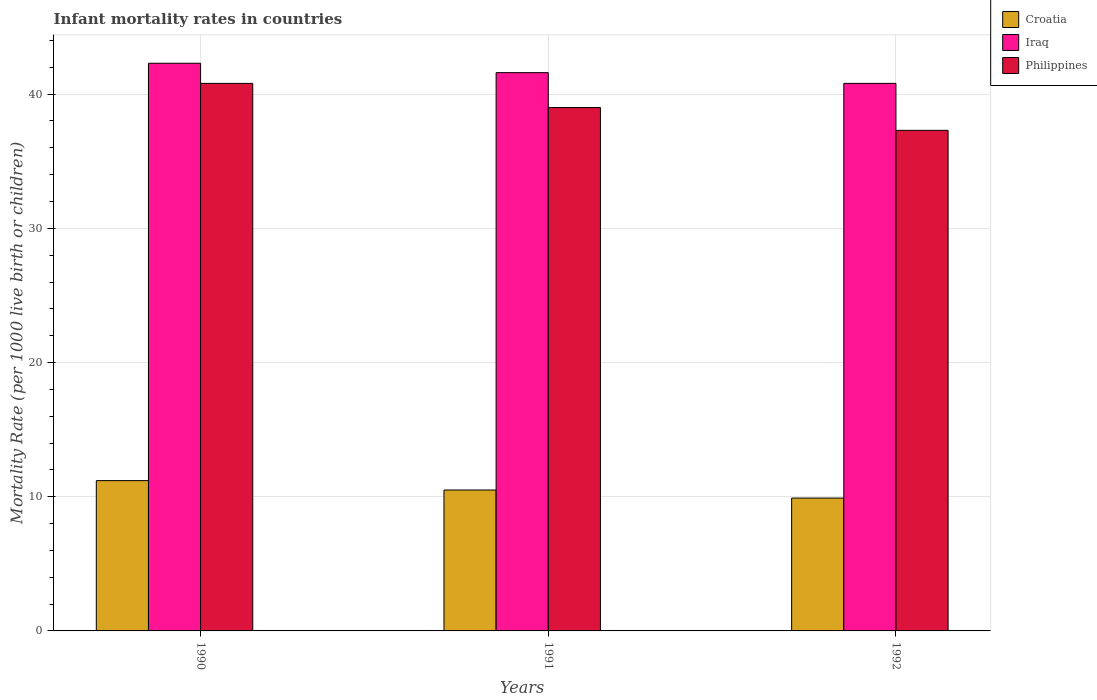How many different coloured bars are there?
Provide a short and direct response. 3. How many bars are there on the 3rd tick from the left?
Make the answer very short. 3. What is the label of the 1st group of bars from the left?
Keep it short and to the point. 1990. What is the infant mortality rate in Iraq in 1992?
Provide a short and direct response. 40.8. Across all years, what is the maximum infant mortality rate in Philippines?
Give a very brief answer. 40.8. In which year was the infant mortality rate in Croatia maximum?
Make the answer very short. 1990. In which year was the infant mortality rate in Croatia minimum?
Your answer should be compact. 1992. What is the total infant mortality rate in Croatia in the graph?
Your answer should be very brief. 31.6. What is the difference between the infant mortality rate in Croatia in 1991 and that in 1992?
Your response must be concise. 0.6. What is the difference between the infant mortality rate in Philippines in 1992 and the infant mortality rate in Croatia in 1990?
Ensure brevity in your answer.  26.1. What is the average infant mortality rate in Philippines per year?
Provide a succinct answer. 39.03. In the year 1991, what is the difference between the infant mortality rate in Philippines and infant mortality rate in Iraq?
Make the answer very short. -2.6. What is the ratio of the infant mortality rate in Philippines in 1990 to that in 1991?
Your response must be concise. 1.05. Is the infant mortality rate in Philippines in 1991 less than that in 1992?
Provide a short and direct response. No. Is the difference between the infant mortality rate in Philippines in 1990 and 1992 greater than the difference between the infant mortality rate in Iraq in 1990 and 1992?
Provide a succinct answer. Yes. What is the difference between the highest and the second highest infant mortality rate in Philippines?
Your answer should be compact. 1.8. What is the difference between the highest and the lowest infant mortality rate in Philippines?
Make the answer very short. 3.5. Is the sum of the infant mortality rate in Croatia in 1991 and 1992 greater than the maximum infant mortality rate in Philippines across all years?
Your response must be concise. No. What does the 1st bar from the left in 1990 represents?
Your response must be concise. Croatia. What does the 2nd bar from the right in 1991 represents?
Provide a short and direct response. Iraq. Is it the case that in every year, the sum of the infant mortality rate in Philippines and infant mortality rate in Croatia is greater than the infant mortality rate in Iraq?
Provide a succinct answer. Yes. What is the difference between two consecutive major ticks on the Y-axis?
Your answer should be compact. 10. Does the graph contain any zero values?
Offer a terse response. No. How many legend labels are there?
Ensure brevity in your answer.  3. How are the legend labels stacked?
Your answer should be compact. Vertical. What is the title of the graph?
Provide a succinct answer. Infant mortality rates in countries. What is the label or title of the X-axis?
Give a very brief answer. Years. What is the label or title of the Y-axis?
Keep it short and to the point. Mortality Rate (per 1000 live birth or children). What is the Mortality Rate (per 1000 live birth or children) of Croatia in 1990?
Keep it short and to the point. 11.2. What is the Mortality Rate (per 1000 live birth or children) in Iraq in 1990?
Ensure brevity in your answer.  42.3. What is the Mortality Rate (per 1000 live birth or children) in Philippines in 1990?
Your response must be concise. 40.8. What is the Mortality Rate (per 1000 live birth or children) in Croatia in 1991?
Your response must be concise. 10.5. What is the Mortality Rate (per 1000 live birth or children) in Iraq in 1991?
Give a very brief answer. 41.6. What is the Mortality Rate (per 1000 live birth or children) of Croatia in 1992?
Make the answer very short. 9.9. What is the Mortality Rate (per 1000 live birth or children) in Iraq in 1992?
Your response must be concise. 40.8. What is the Mortality Rate (per 1000 live birth or children) in Philippines in 1992?
Ensure brevity in your answer.  37.3. Across all years, what is the maximum Mortality Rate (per 1000 live birth or children) in Croatia?
Ensure brevity in your answer.  11.2. Across all years, what is the maximum Mortality Rate (per 1000 live birth or children) of Iraq?
Keep it short and to the point. 42.3. Across all years, what is the maximum Mortality Rate (per 1000 live birth or children) in Philippines?
Offer a terse response. 40.8. Across all years, what is the minimum Mortality Rate (per 1000 live birth or children) in Iraq?
Provide a short and direct response. 40.8. Across all years, what is the minimum Mortality Rate (per 1000 live birth or children) of Philippines?
Offer a terse response. 37.3. What is the total Mortality Rate (per 1000 live birth or children) in Croatia in the graph?
Your answer should be compact. 31.6. What is the total Mortality Rate (per 1000 live birth or children) in Iraq in the graph?
Provide a short and direct response. 124.7. What is the total Mortality Rate (per 1000 live birth or children) in Philippines in the graph?
Your answer should be compact. 117.1. What is the difference between the Mortality Rate (per 1000 live birth or children) of Croatia in 1990 and that in 1991?
Your answer should be compact. 0.7. What is the difference between the Mortality Rate (per 1000 live birth or children) in Iraq in 1990 and that in 1991?
Keep it short and to the point. 0.7. What is the difference between the Mortality Rate (per 1000 live birth or children) of Philippines in 1990 and that in 1991?
Give a very brief answer. 1.8. What is the difference between the Mortality Rate (per 1000 live birth or children) of Croatia in 1990 and that in 1992?
Ensure brevity in your answer.  1.3. What is the difference between the Mortality Rate (per 1000 live birth or children) of Iraq in 1990 and that in 1992?
Offer a terse response. 1.5. What is the difference between the Mortality Rate (per 1000 live birth or children) in Philippines in 1990 and that in 1992?
Your answer should be compact. 3.5. What is the difference between the Mortality Rate (per 1000 live birth or children) in Iraq in 1991 and that in 1992?
Provide a succinct answer. 0.8. What is the difference between the Mortality Rate (per 1000 live birth or children) in Croatia in 1990 and the Mortality Rate (per 1000 live birth or children) in Iraq in 1991?
Keep it short and to the point. -30.4. What is the difference between the Mortality Rate (per 1000 live birth or children) in Croatia in 1990 and the Mortality Rate (per 1000 live birth or children) in Philippines in 1991?
Keep it short and to the point. -27.8. What is the difference between the Mortality Rate (per 1000 live birth or children) in Iraq in 1990 and the Mortality Rate (per 1000 live birth or children) in Philippines in 1991?
Give a very brief answer. 3.3. What is the difference between the Mortality Rate (per 1000 live birth or children) in Croatia in 1990 and the Mortality Rate (per 1000 live birth or children) in Iraq in 1992?
Keep it short and to the point. -29.6. What is the difference between the Mortality Rate (per 1000 live birth or children) of Croatia in 1990 and the Mortality Rate (per 1000 live birth or children) of Philippines in 1992?
Provide a succinct answer. -26.1. What is the difference between the Mortality Rate (per 1000 live birth or children) in Iraq in 1990 and the Mortality Rate (per 1000 live birth or children) in Philippines in 1992?
Ensure brevity in your answer.  5. What is the difference between the Mortality Rate (per 1000 live birth or children) of Croatia in 1991 and the Mortality Rate (per 1000 live birth or children) of Iraq in 1992?
Your answer should be very brief. -30.3. What is the difference between the Mortality Rate (per 1000 live birth or children) of Croatia in 1991 and the Mortality Rate (per 1000 live birth or children) of Philippines in 1992?
Give a very brief answer. -26.8. What is the difference between the Mortality Rate (per 1000 live birth or children) of Iraq in 1991 and the Mortality Rate (per 1000 live birth or children) of Philippines in 1992?
Ensure brevity in your answer.  4.3. What is the average Mortality Rate (per 1000 live birth or children) in Croatia per year?
Your answer should be very brief. 10.53. What is the average Mortality Rate (per 1000 live birth or children) in Iraq per year?
Your response must be concise. 41.57. What is the average Mortality Rate (per 1000 live birth or children) in Philippines per year?
Offer a very short reply. 39.03. In the year 1990, what is the difference between the Mortality Rate (per 1000 live birth or children) of Croatia and Mortality Rate (per 1000 live birth or children) of Iraq?
Your answer should be compact. -31.1. In the year 1990, what is the difference between the Mortality Rate (per 1000 live birth or children) of Croatia and Mortality Rate (per 1000 live birth or children) of Philippines?
Your response must be concise. -29.6. In the year 1990, what is the difference between the Mortality Rate (per 1000 live birth or children) of Iraq and Mortality Rate (per 1000 live birth or children) of Philippines?
Give a very brief answer. 1.5. In the year 1991, what is the difference between the Mortality Rate (per 1000 live birth or children) of Croatia and Mortality Rate (per 1000 live birth or children) of Iraq?
Your answer should be very brief. -31.1. In the year 1991, what is the difference between the Mortality Rate (per 1000 live birth or children) of Croatia and Mortality Rate (per 1000 live birth or children) of Philippines?
Make the answer very short. -28.5. In the year 1991, what is the difference between the Mortality Rate (per 1000 live birth or children) of Iraq and Mortality Rate (per 1000 live birth or children) of Philippines?
Your response must be concise. 2.6. In the year 1992, what is the difference between the Mortality Rate (per 1000 live birth or children) in Croatia and Mortality Rate (per 1000 live birth or children) in Iraq?
Make the answer very short. -30.9. In the year 1992, what is the difference between the Mortality Rate (per 1000 live birth or children) of Croatia and Mortality Rate (per 1000 live birth or children) of Philippines?
Offer a terse response. -27.4. In the year 1992, what is the difference between the Mortality Rate (per 1000 live birth or children) of Iraq and Mortality Rate (per 1000 live birth or children) of Philippines?
Make the answer very short. 3.5. What is the ratio of the Mortality Rate (per 1000 live birth or children) of Croatia in 1990 to that in 1991?
Keep it short and to the point. 1.07. What is the ratio of the Mortality Rate (per 1000 live birth or children) in Iraq in 1990 to that in 1991?
Provide a short and direct response. 1.02. What is the ratio of the Mortality Rate (per 1000 live birth or children) of Philippines in 1990 to that in 1991?
Make the answer very short. 1.05. What is the ratio of the Mortality Rate (per 1000 live birth or children) of Croatia in 1990 to that in 1992?
Provide a short and direct response. 1.13. What is the ratio of the Mortality Rate (per 1000 live birth or children) of Iraq in 1990 to that in 1992?
Offer a very short reply. 1.04. What is the ratio of the Mortality Rate (per 1000 live birth or children) of Philippines in 1990 to that in 1992?
Provide a short and direct response. 1.09. What is the ratio of the Mortality Rate (per 1000 live birth or children) in Croatia in 1991 to that in 1992?
Provide a short and direct response. 1.06. What is the ratio of the Mortality Rate (per 1000 live birth or children) in Iraq in 1991 to that in 1992?
Give a very brief answer. 1.02. What is the ratio of the Mortality Rate (per 1000 live birth or children) of Philippines in 1991 to that in 1992?
Keep it short and to the point. 1.05. What is the difference between the highest and the lowest Mortality Rate (per 1000 live birth or children) of Croatia?
Give a very brief answer. 1.3. What is the difference between the highest and the lowest Mortality Rate (per 1000 live birth or children) in Iraq?
Your answer should be compact. 1.5. 